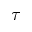<formula> <loc_0><loc_0><loc_500><loc_500>\tau</formula> 